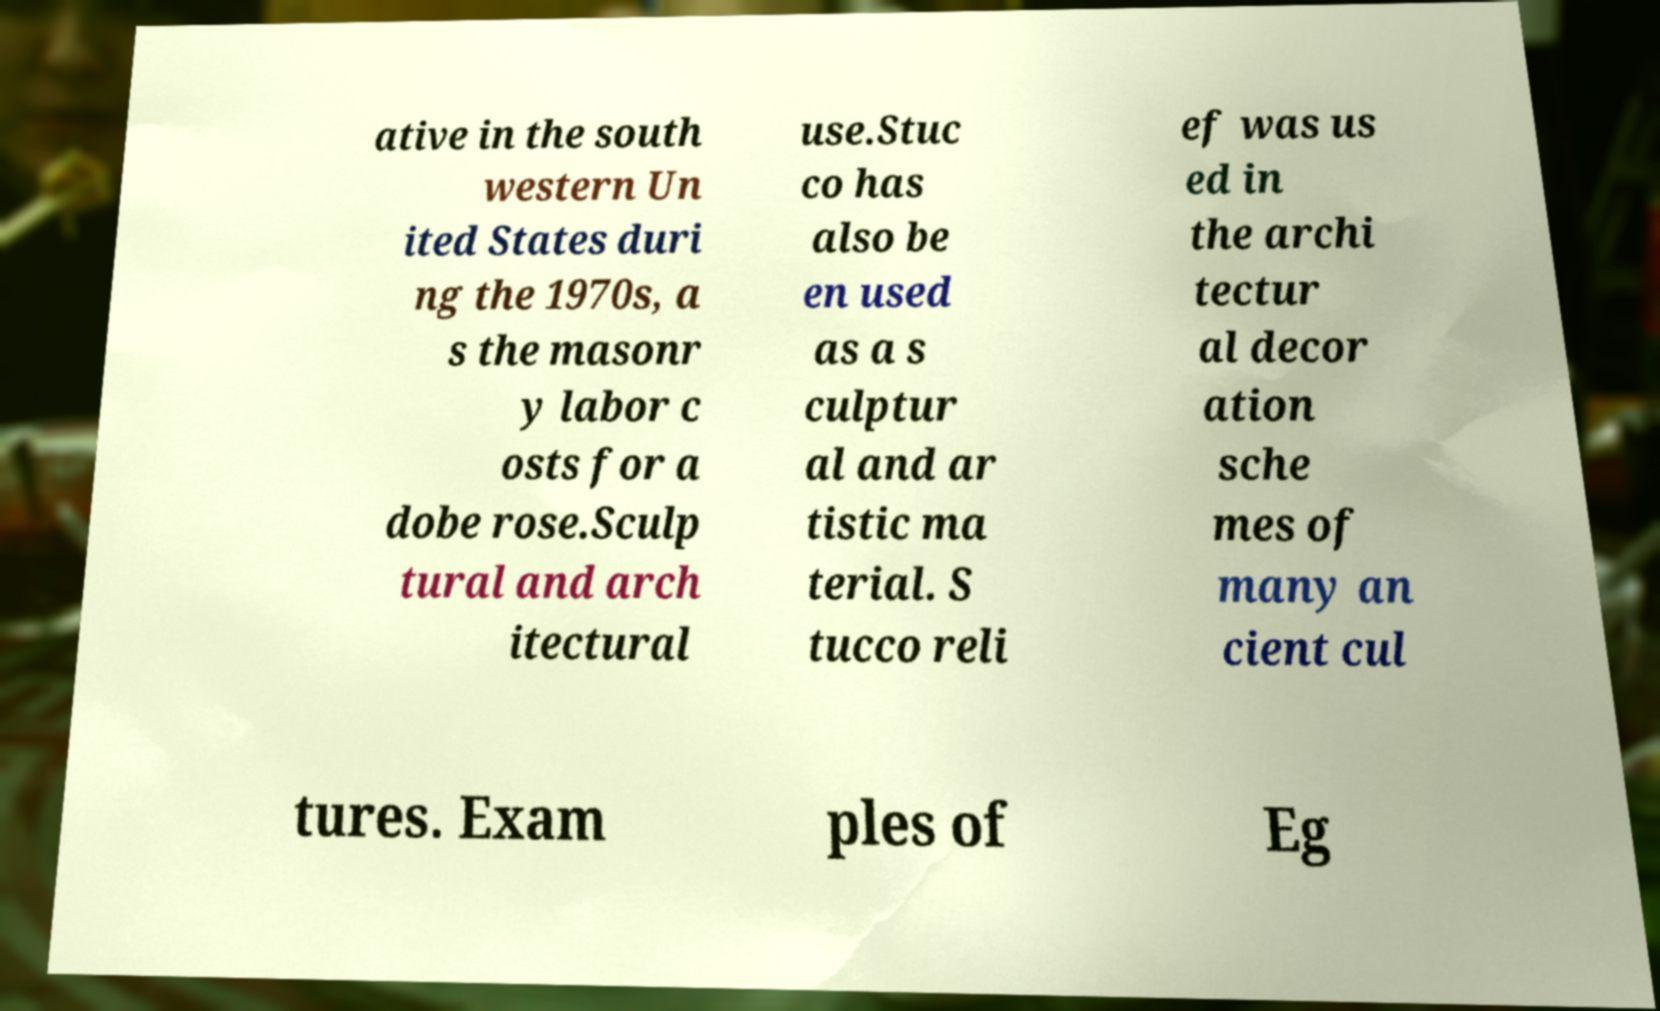I need the written content from this picture converted into text. Can you do that? ative in the south western Un ited States duri ng the 1970s, a s the masonr y labor c osts for a dobe rose.Sculp tural and arch itectural use.Stuc co has also be en used as a s culptur al and ar tistic ma terial. S tucco reli ef was us ed in the archi tectur al decor ation sche mes of many an cient cul tures. Exam ples of Eg 